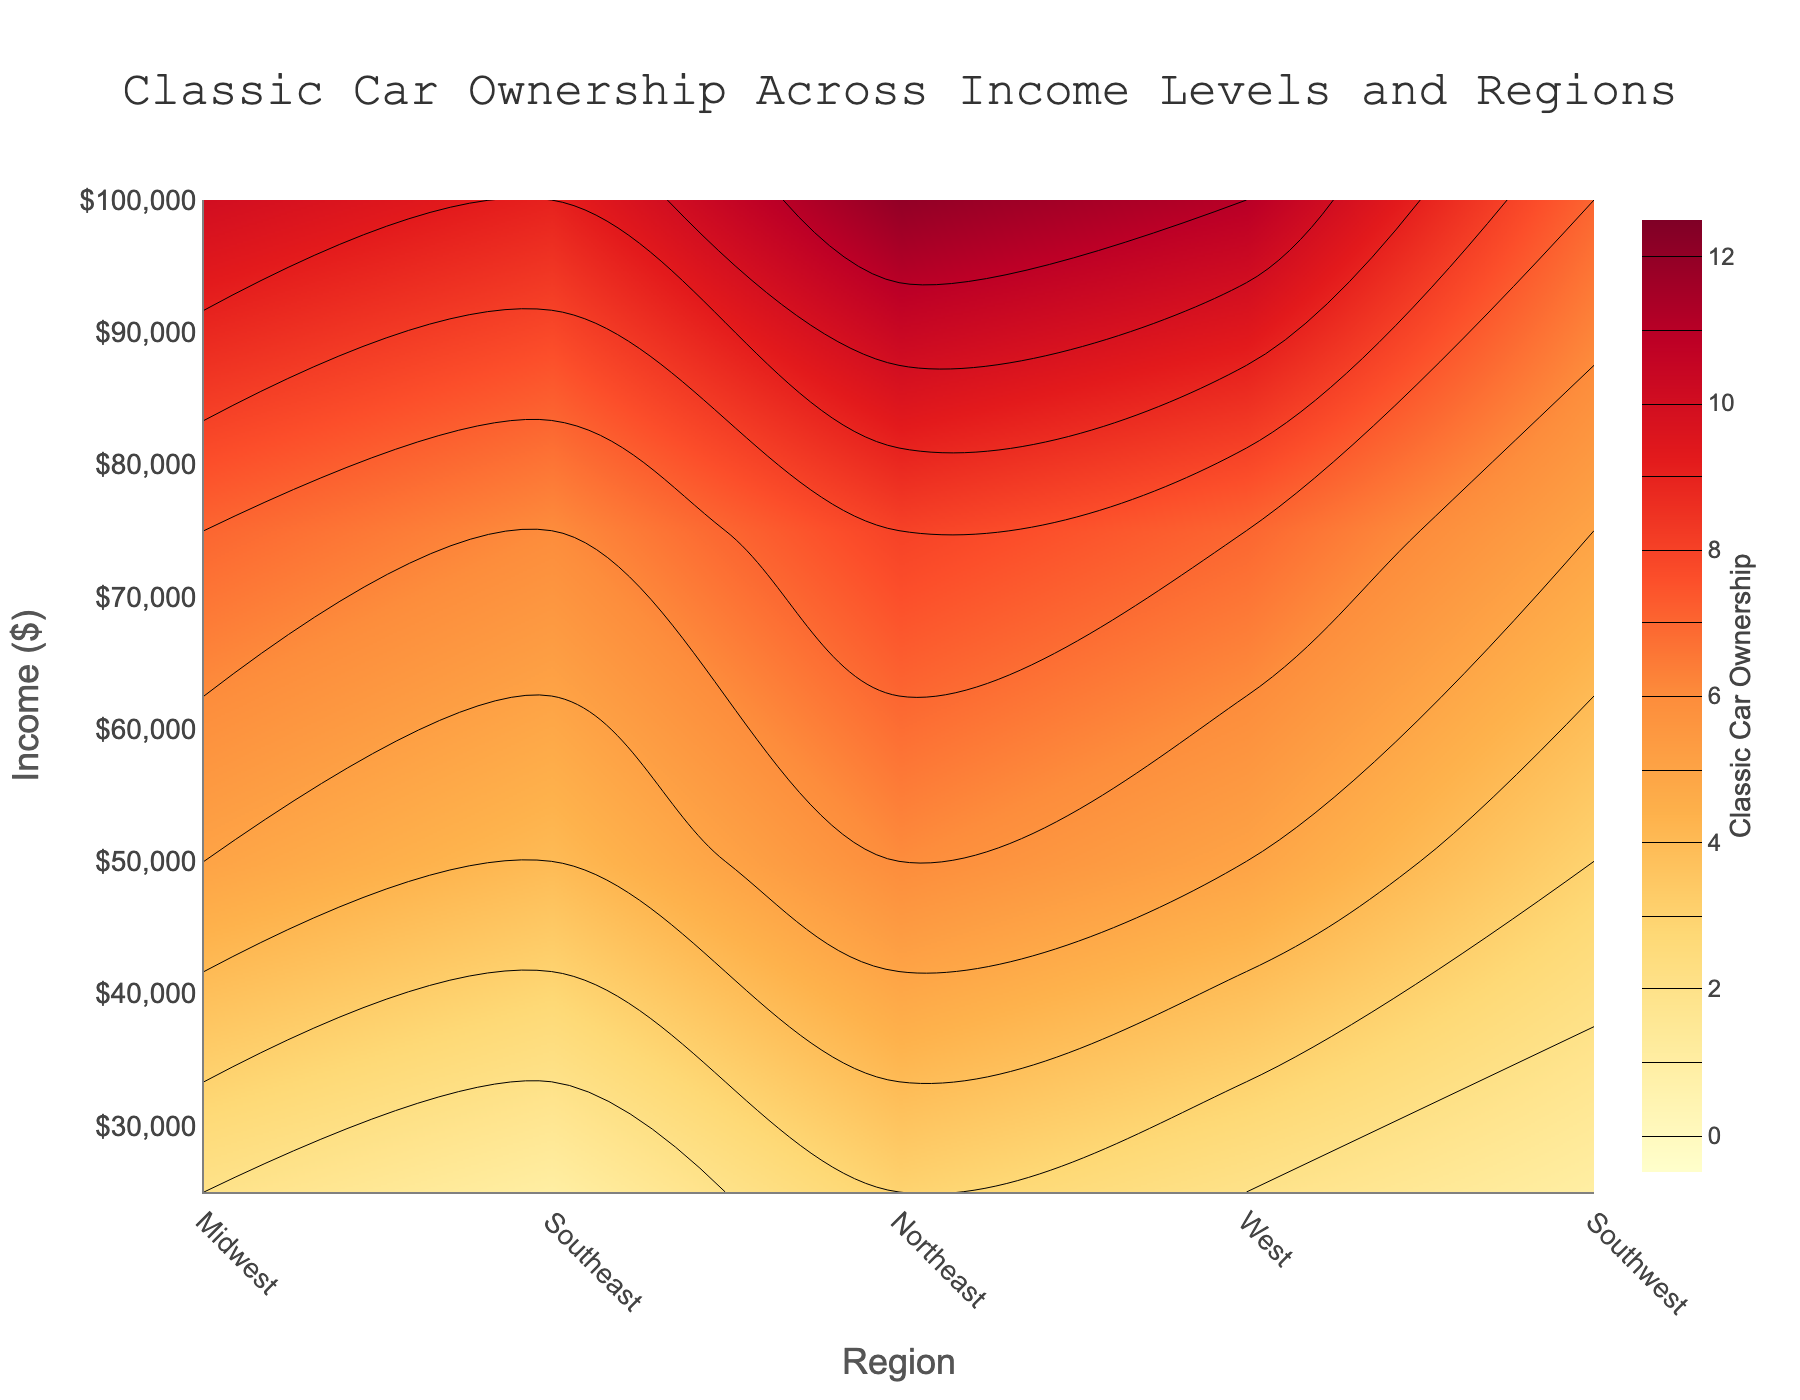What is the title of the plot? The plot's title is prominently displayed at the top center of the figure, and it succinctly summarizes the visualization.
Answer: "Classic Car Ownership Across Income Levels and Regions" What colors are used in the plot? The contour plot uses a color scheme ranging from light yellow to dark red to represent different levels of classic car ownership.
Answer: Yellow to Red Which region has the highest classic car ownership at an income of $100,000? By observing the contour plot, at the income level of $100,000, the Southeast region has the darkest red color, indicating the highest classic car ownership.
Answer: Southeast How does classic car ownership change with increasing income in the Northeast? In the Northeast region, classic car ownership increases gradually as we move vertically up from $25,000 to $100,000, with the color evolving from light to darker shades.
Answer: It increases Which regions show the most noticeable increase in classic car ownership as income rises? Both the Southeast and Midwest regions exhibit a noticeable gradient, with ownership increasing significantly from lower to higher income levels.
Answer: Southeast and Midwest At an income of $50,000, which region has the lowest classic car ownership? By cross-referencing regions at the income level of $50,000, the West region is represented by the lightest color, indicating the lowest ownership.
Answer: West Compare the classic car ownership between the Southwest and Midwest regions at an income of $75,000. The contour plot shows that at $75,000 income, both regions have dark shades, but the Southwest has slightly darker shades compared to the Midwest.
Answer: Southwest has higher ownership What pattern can be observed in classic car ownership in the Midwest region as income increases? The Midwest region gradually transitions from lighter to darker shades as income increases from $25,000 to $100,000, indicating higher car ownership with higher income.
Answer: Gradual increase Does any region have consistent classic car ownership across all income levels? The contour plot does not show such consistency; all regions display a gradient in ownership, indicating variations with income levels.
Answer: No 